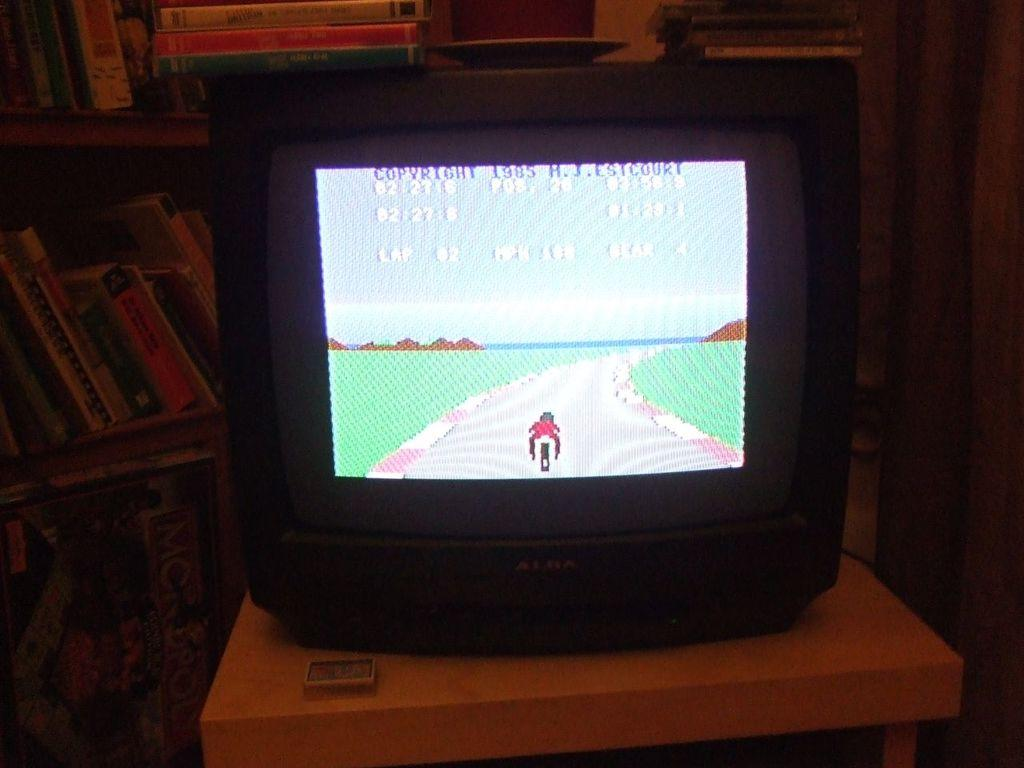<image>
Share a concise interpretation of the image provided. A television screen is showing a racing video game copyrighted in 1985. 